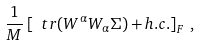Convert formula to latex. <formula><loc_0><loc_0><loc_500><loc_500>\frac { 1 } { M } \left [ \ t r ( W ^ { \alpha } W _ { \alpha } \Sigma ) + h . c . \right ] _ { F } \, ,</formula> 